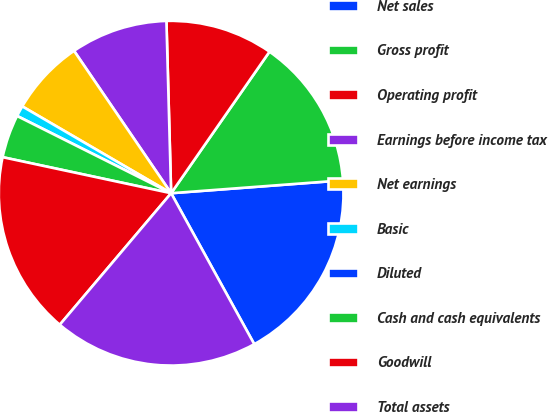<chart> <loc_0><loc_0><loc_500><loc_500><pie_chart><fcel>Net sales<fcel>Gross profit<fcel>Operating profit<fcel>Earnings before income tax<fcel>Net earnings<fcel>Basic<fcel>Diluted<fcel>Cash and cash equivalents<fcel>Goodwill<fcel>Total assets<nl><fcel>18.18%<fcel>14.14%<fcel>10.1%<fcel>9.09%<fcel>7.07%<fcel>1.01%<fcel>0.0%<fcel>4.04%<fcel>17.17%<fcel>19.19%<nl></chart> 